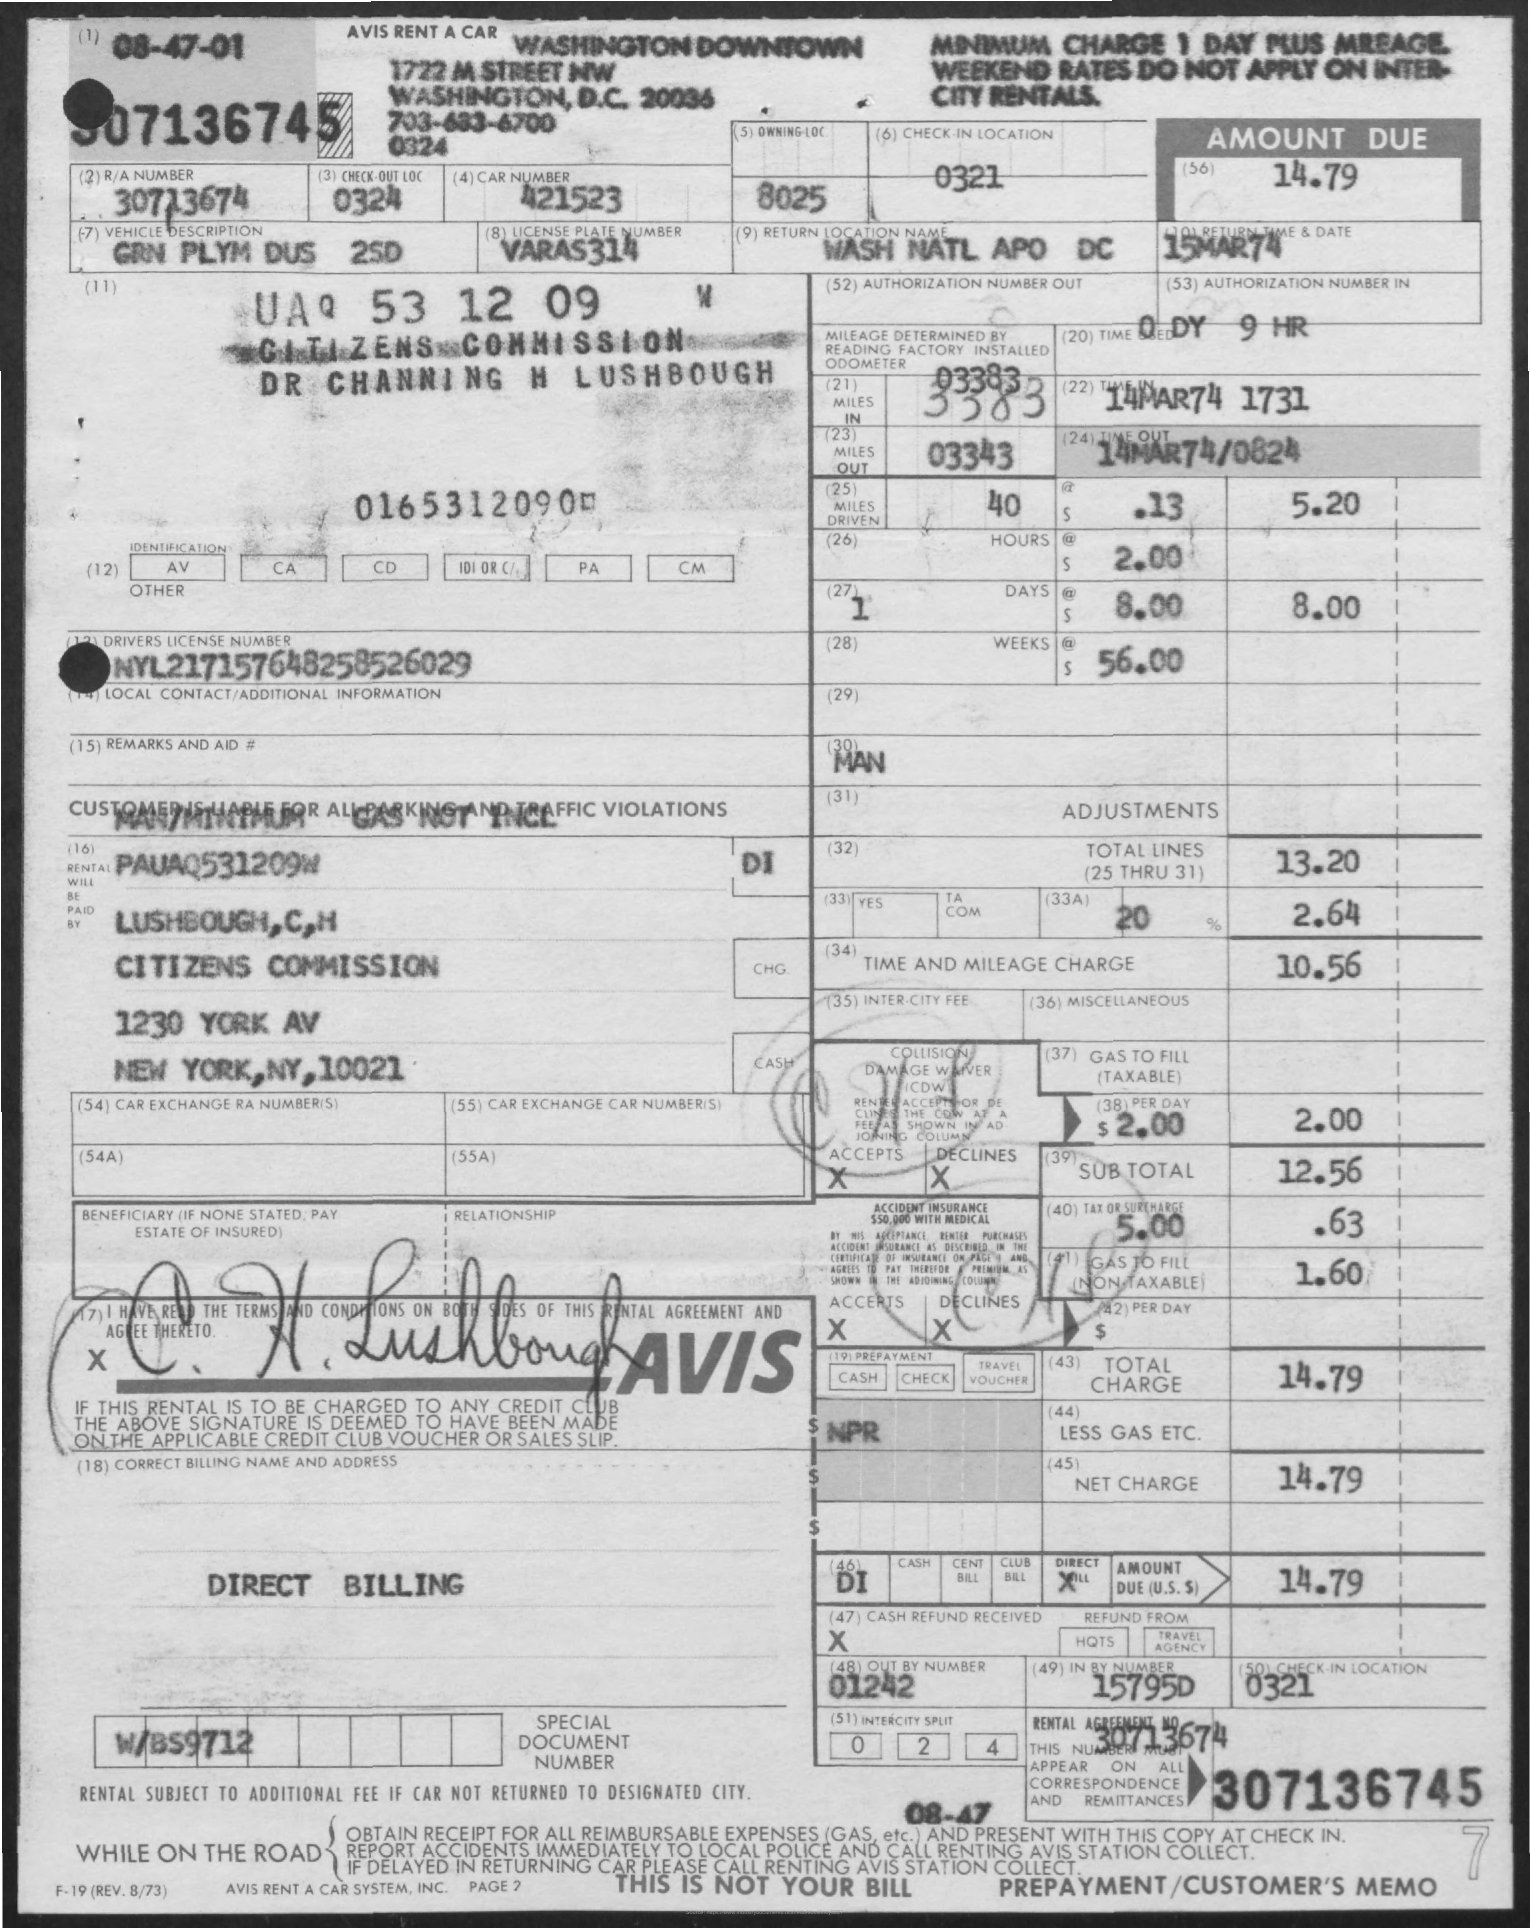Can you tell me what date the car was rented? The car was rented on April 7, 1981, as shown in the top left corner of the rental agreement. 